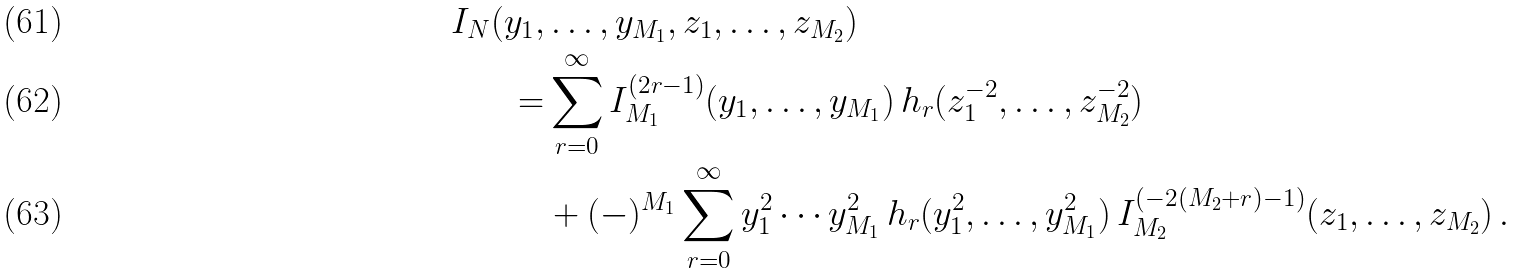Convert formula to latex. <formula><loc_0><loc_0><loc_500><loc_500>I _ { N } ( y _ { 1 } , & \dots , y _ { M _ { 1 } } , z _ { 1 } , \dots , z _ { M _ { 2 } } ) \\ = & \sum _ { r = 0 } ^ { \infty } I _ { M _ { 1 } } ^ { ( 2 r - 1 ) } ( y _ { 1 } , \dots , y _ { M _ { 1 } } ) \, h _ { r } ( z _ { 1 } ^ { - 2 } , \dots , z _ { M _ { 2 } } ^ { - 2 } ) \\ & + ( - ) ^ { M _ { 1 } } \sum _ { r = 0 } ^ { \infty } y _ { 1 } ^ { 2 } \cdots y _ { M _ { 1 } } ^ { 2 } \, h _ { r } ( y _ { 1 } ^ { 2 } , \dots , y _ { M _ { 1 } } ^ { 2 } ) \, I _ { M _ { 2 } } ^ { ( - 2 ( M _ { 2 } + r ) - 1 ) } ( z _ { 1 } , \dots , z _ { M _ { 2 } } ) \, .</formula> 